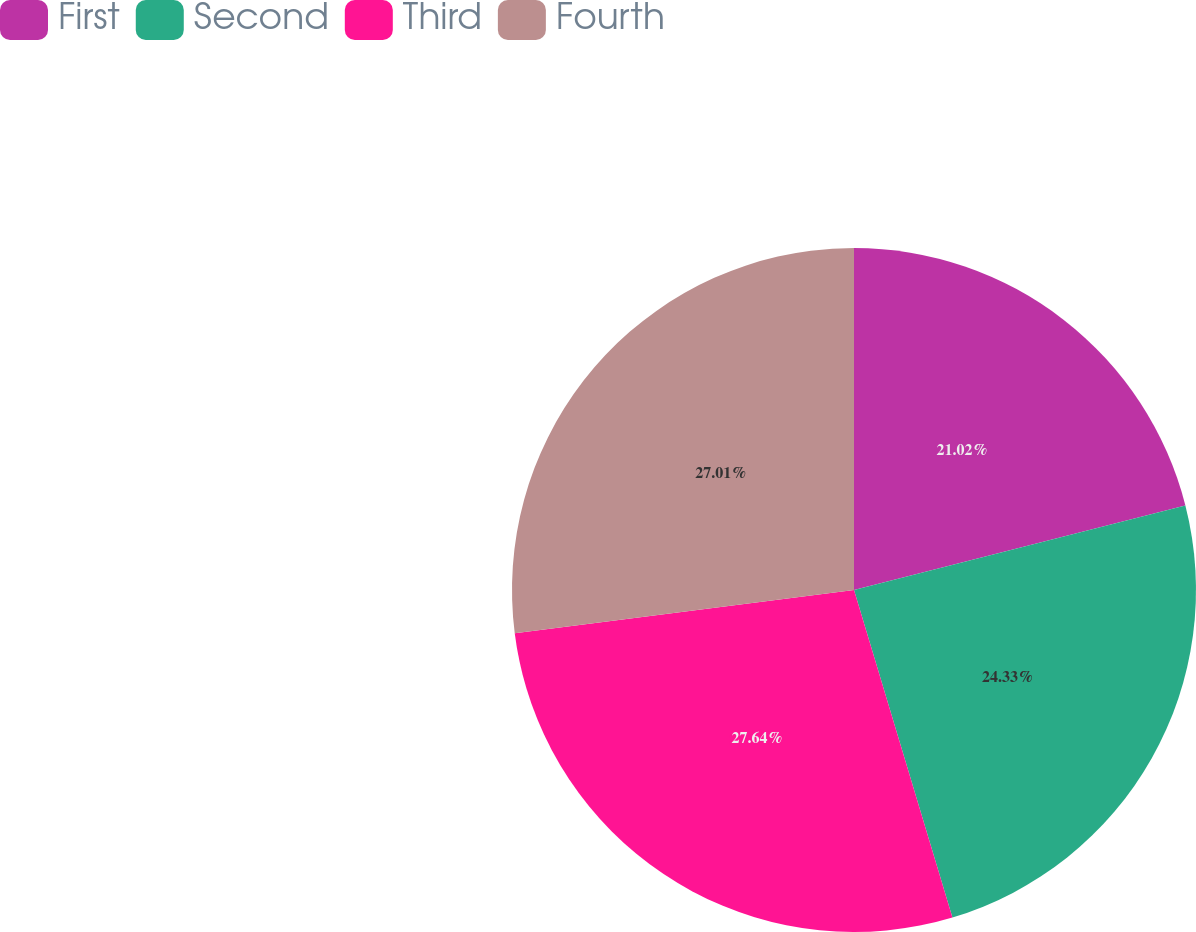Convert chart. <chart><loc_0><loc_0><loc_500><loc_500><pie_chart><fcel>First<fcel>Second<fcel>Third<fcel>Fourth<nl><fcel>21.02%<fcel>24.33%<fcel>27.63%<fcel>27.01%<nl></chart> 